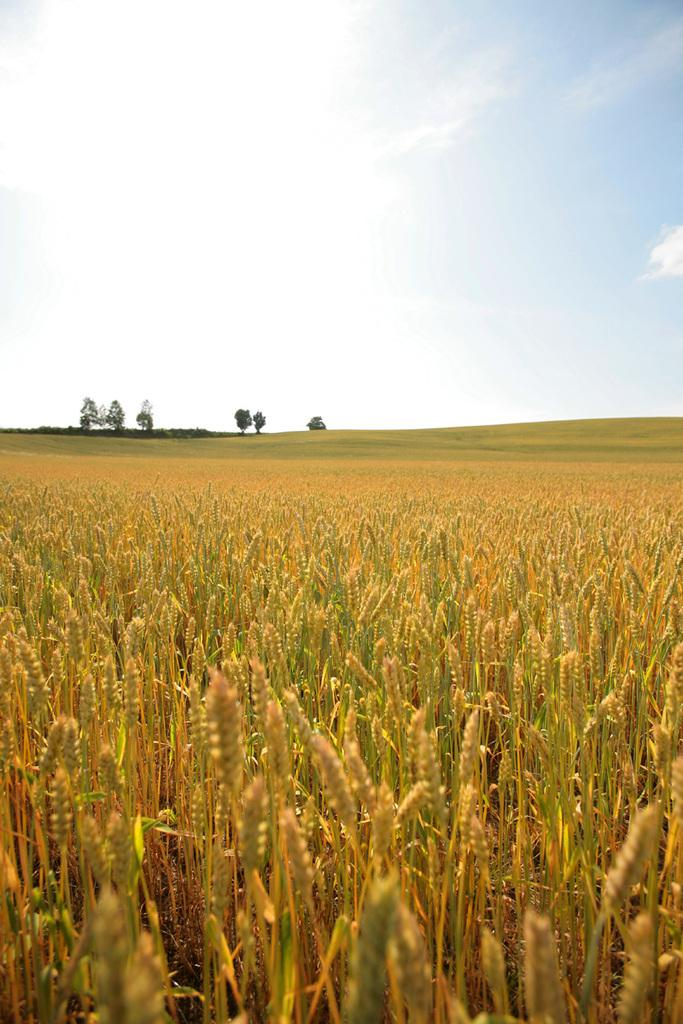What type of crops can be seen in the image? There are farmlands of wheat grains in the image. What other natural elements are visible in the image? There are trees in the background of the image. What is the condition of the sky in the image? The sky is clear and visible in the background of the image. What time of day is it in the image, based on the position of the bushes? There are no bushes mentioned in the image, and therefore their position cannot be used to determine the time of day. 